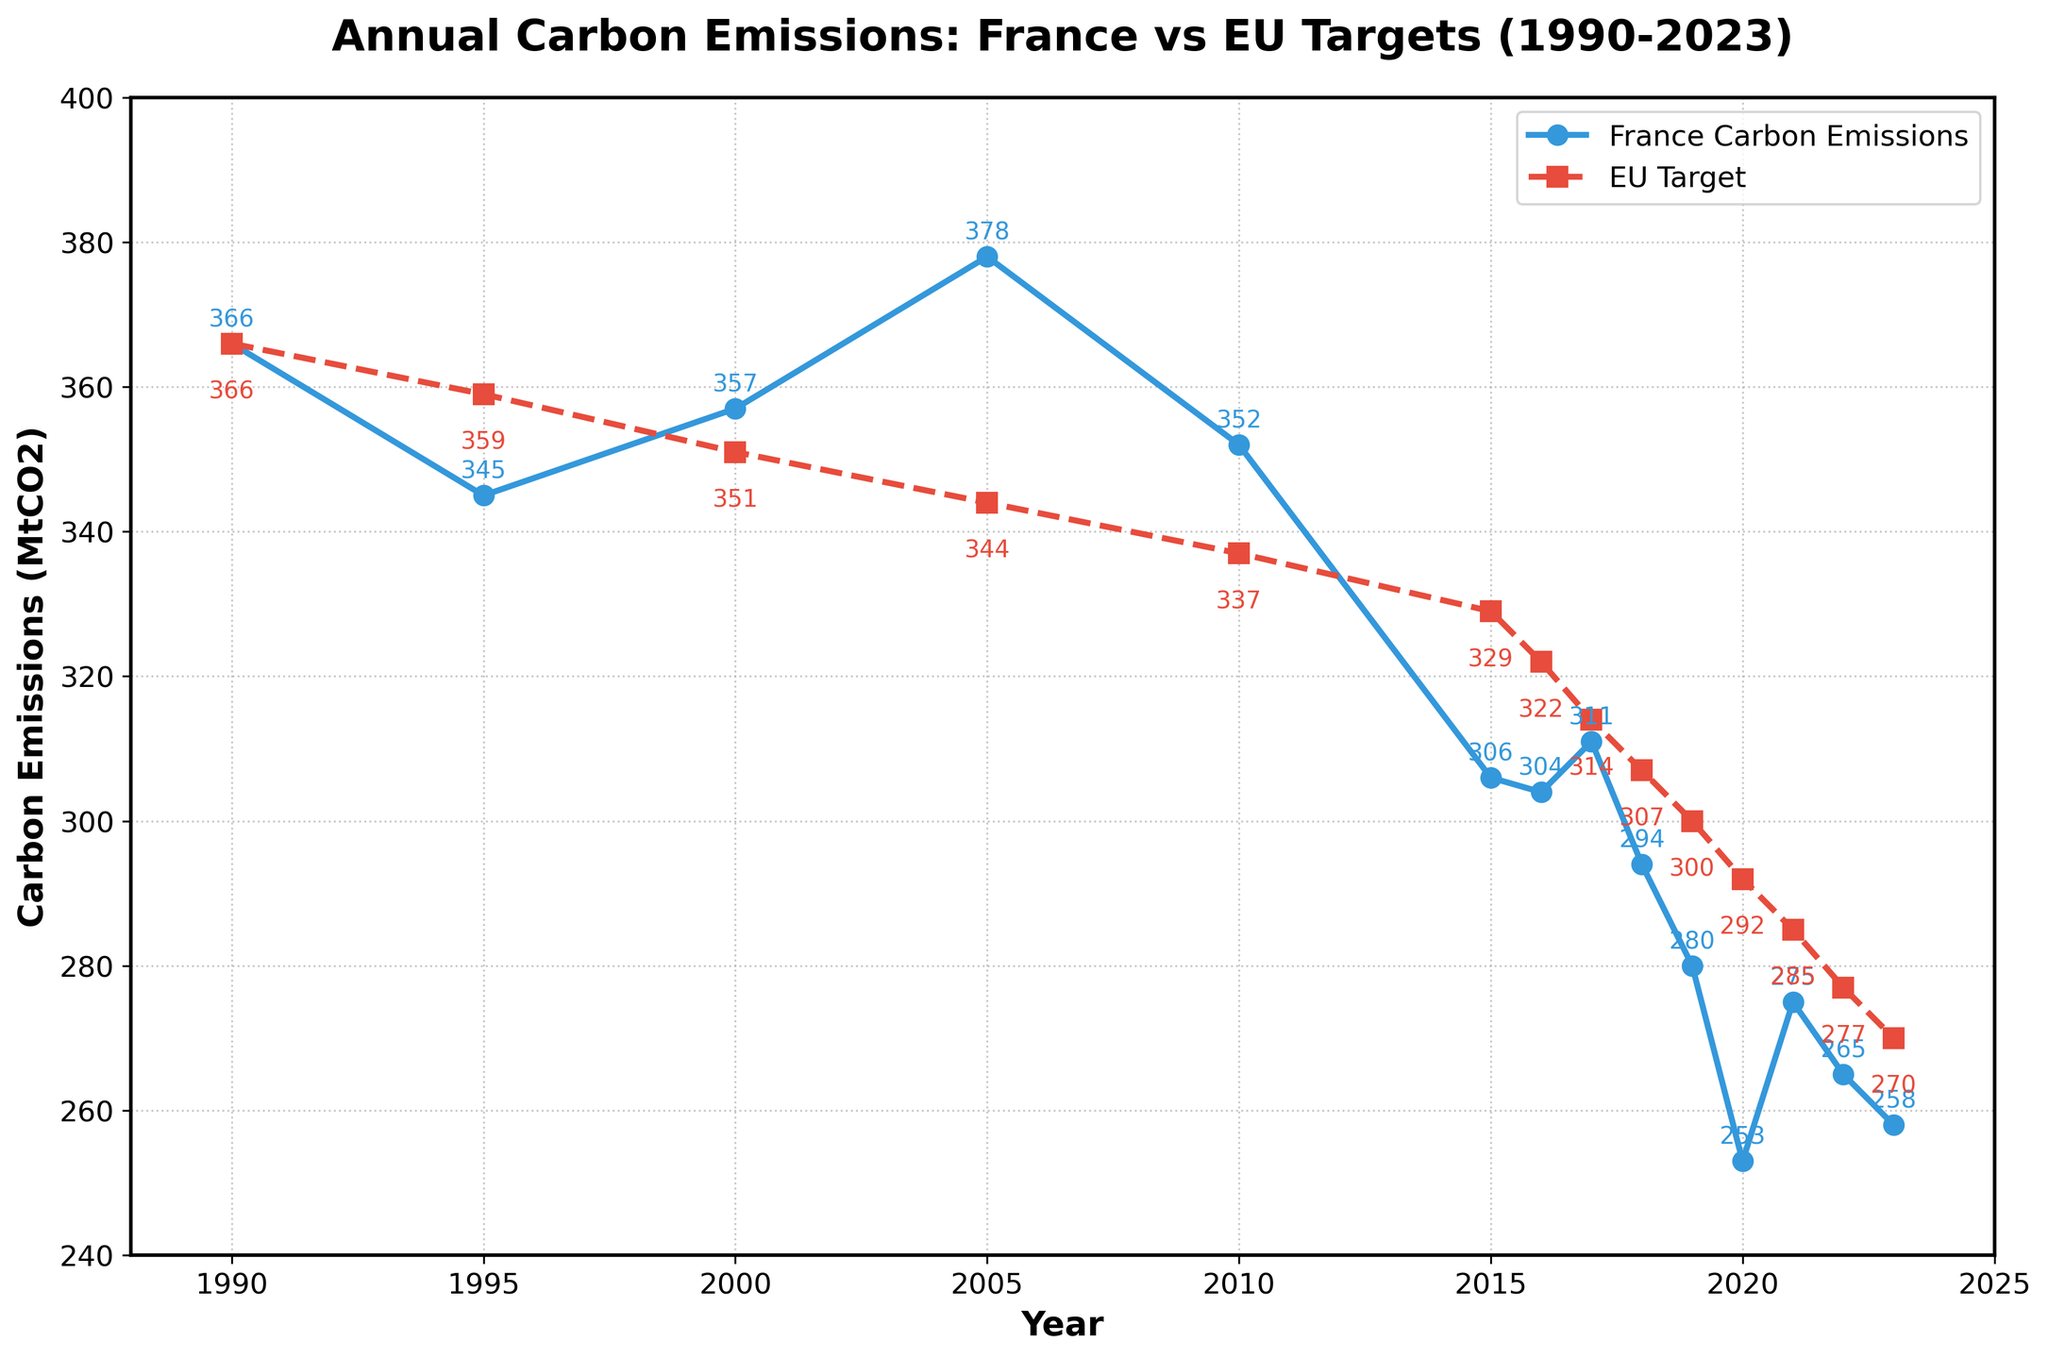What year did France's carbon emissions exceed the EU target the most? To find the year when the difference between France's carbon emissions and the EU target is the largest, we can visually inspect the graph and identify the year with the widest gap between the blue and red lines. The year 2005 shows France's emissions at 378 MtCO2 and the EU target at 344 MtCO2, resulting in a gap of 34 MtCO2.
Answer: 2005 What was the approximate difference between France's carbon emissions and the EU targets in 2023? To determine the difference, locate the data points for 2023: France's emissions are 258 MtCO2, and the EU target is 270 MtCO2. Subtracting these values gives 270 - 258 = 12 MtCO2.
Answer: 12 MtCO2 Between which two consecutive years did France's carbon emissions decrease the most? To find the largest decrease, examine the plot for the steepest downward slope between consecutive years. From 2019 to 2020, emissions dropped from 280 MtCO2 to 253 MtCO2, a decrease of 27 MtCO2 (280 - 253).
Answer: 2019 to 2020 What is the trend in France's carbon emissions from 1990 to 2023, and how does it compare to the EU target trend? To understand the trend, observe the overall direction of the blue (France) and red (EU target) lines. France's emissions show fluctuations but generally decrease over time from 366 MtCO2 to 258 MtCO2. The EU targets consistently decrease with slight variations, indicating a clearer downward trend. Both show an overall reducing trend.
Answer: Both are decreasing When did France's carbon emissions first fall below the EU targets? Locate the point where the blue line (France) first moves below the red line (EU target). This occurs in 2020 when France's emissions were 253 MtCO2 compared to the EU target of 292 MtCO2.
Answer: 2020 How many years did France's carbon emissions stay above the EU targets within the provided data range? Count the number of years where the blue line (France's emissions) is above the red line (EU targets). From 1990 to 2019, with the exception of 2015 and 2016, France's emissions stayed above the EU targets. Thus, 2020-2023 (inclusive) are 4 below-target years, totaling 26 - 4 = 22 years above target.
Answer: 22 years What was the maximum carbon emissions of France during the given period? To identify the peak emissions, assess the highest point on the blue line representing France's emissions. The highest value is in 2005 at 378 MtCO2.
Answer: 378 MtCO2 What's the average of France's carbon emissions over the period 1990-2023? Compute the average by summing the emissions for all years and dividing by the number of years. The sum is 366 + 345 + 357 + 378 + 352 + 306 + 304 + 311 + 294 + 280 + 253 + 275 + 265 + 258 = 4644. There are 14 years, so the average is 4644 / 14 ≈ 331.71 MtCO2.
Answer: 331.71 MtCO2 